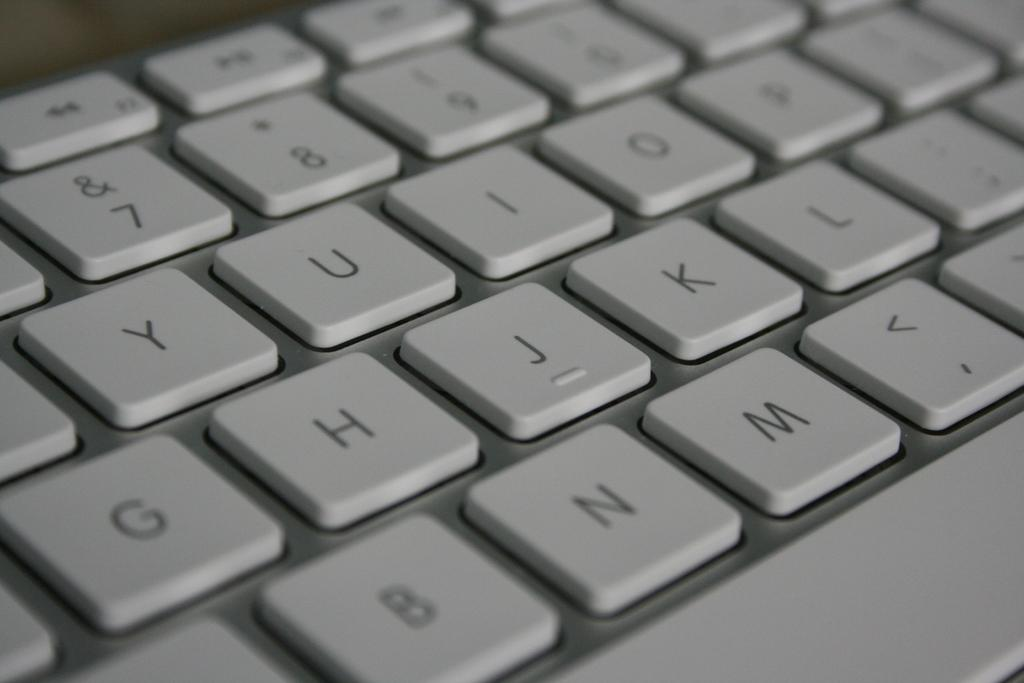What is the main object in the image? There is a keyboard in the image. What color is the keyboard? The keyboard is white in color. What type of reaction can be seen in the oven in the image? There is no oven present in the image, so it is not possible to observe any reactions. 